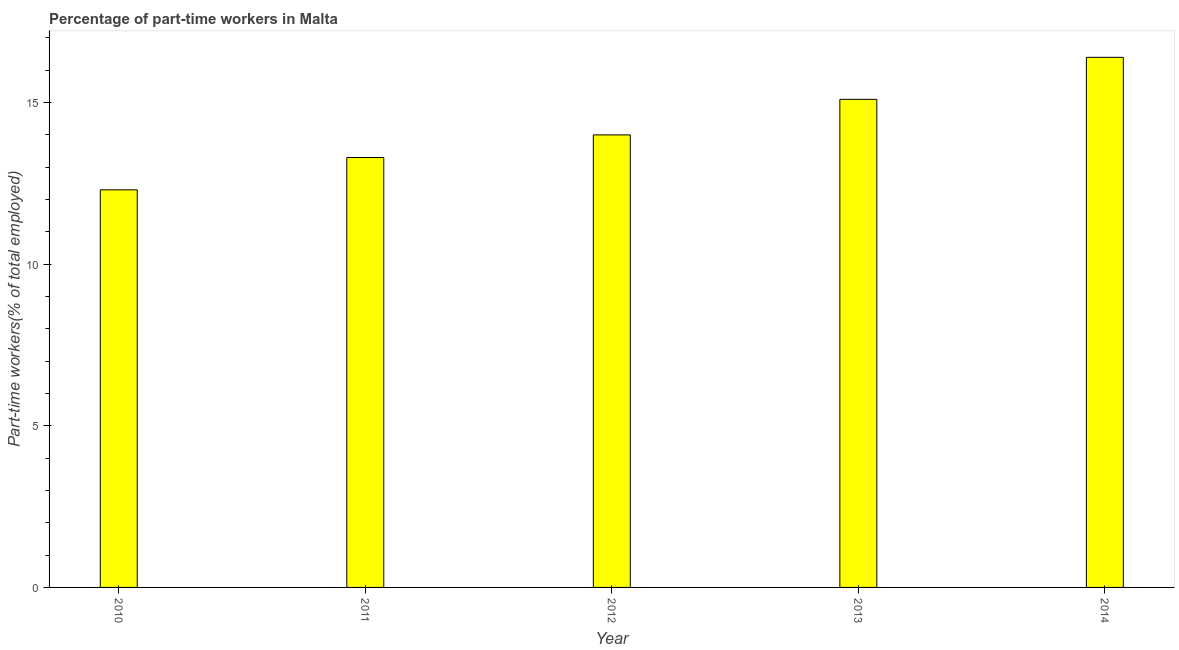Does the graph contain any zero values?
Your answer should be very brief. No. What is the title of the graph?
Offer a very short reply. Percentage of part-time workers in Malta. What is the label or title of the X-axis?
Ensure brevity in your answer.  Year. What is the label or title of the Y-axis?
Provide a succinct answer. Part-time workers(% of total employed). What is the percentage of part-time workers in 2010?
Provide a short and direct response. 12.3. Across all years, what is the maximum percentage of part-time workers?
Ensure brevity in your answer.  16.4. Across all years, what is the minimum percentage of part-time workers?
Provide a succinct answer. 12.3. In which year was the percentage of part-time workers minimum?
Your answer should be compact. 2010. What is the sum of the percentage of part-time workers?
Ensure brevity in your answer.  71.1. What is the difference between the percentage of part-time workers in 2011 and 2014?
Ensure brevity in your answer.  -3.1. What is the average percentage of part-time workers per year?
Give a very brief answer. 14.22. Do a majority of the years between 2014 and 2012 (inclusive) have percentage of part-time workers greater than 10 %?
Your answer should be very brief. Yes. What is the ratio of the percentage of part-time workers in 2010 to that in 2012?
Ensure brevity in your answer.  0.88. Is the percentage of part-time workers in 2012 less than that in 2014?
Provide a succinct answer. Yes. Is the difference between the percentage of part-time workers in 2010 and 2014 greater than the difference between any two years?
Your answer should be compact. Yes. What is the difference between the highest and the second highest percentage of part-time workers?
Your answer should be very brief. 1.3. Is the sum of the percentage of part-time workers in 2010 and 2014 greater than the maximum percentage of part-time workers across all years?
Your answer should be very brief. Yes. In how many years, is the percentage of part-time workers greater than the average percentage of part-time workers taken over all years?
Keep it short and to the point. 2. How many years are there in the graph?
Offer a very short reply. 5. What is the difference between two consecutive major ticks on the Y-axis?
Offer a terse response. 5. What is the Part-time workers(% of total employed) of 2010?
Offer a very short reply. 12.3. What is the Part-time workers(% of total employed) in 2011?
Your answer should be compact. 13.3. What is the Part-time workers(% of total employed) of 2012?
Provide a short and direct response. 14. What is the Part-time workers(% of total employed) in 2013?
Keep it short and to the point. 15.1. What is the Part-time workers(% of total employed) of 2014?
Ensure brevity in your answer.  16.4. What is the difference between the Part-time workers(% of total employed) in 2010 and 2013?
Provide a succinct answer. -2.8. What is the difference between the Part-time workers(% of total employed) in 2010 and 2014?
Your answer should be compact. -4.1. What is the difference between the Part-time workers(% of total employed) in 2011 and 2012?
Ensure brevity in your answer.  -0.7. What is the difference between the Part-time workers(% of total employed) in 2011 and 2013?
Keep it short and to the point. -1.8. What is the difference between the Part-time workers(% of total employed) in 2012 and 2014?
Make the answer very short. -2.4. What is the ratio of the Part-time workers(% of total employed) in 2010 to that in 2011?
Give a very brief answer. 0.93. What is the ratio of the Part-time workers(% of total employed) in 2010 to that in 2012?
Offer a terse response. 0.88. What is the ratio of the Part-time workers(% of total employed) in 2010 to that in 2013?
Ensure brevity in your answer.  0.81. What is the ratio of the Part-time workers(% of total employed) in 2011 to that in 2012?
Give a very brief answer. 0.95. What is the ratio of the Part-time workers(% of total employed) in 2011 to that in 2013?
Ensure brevity in your answer.  0.88. What is the ratio of the Part-time workers(% of total employed) in 2011 to that in 2014?
Ensure brevity in your answer.  0.81. What is the ratio of the Part-time workers(% of total employed) in 2012 to that in 2013?
Your response must be concise. 0.93. What is the ratio of the Part-time workers(% of total employed) in 2012 to that in 2014?
Provide a succinct answer. 0.85. What is the ratio of the Part-time workers(% of total employed) in 2013 to that in 2014?
Offer a very short reply. 0.92. 